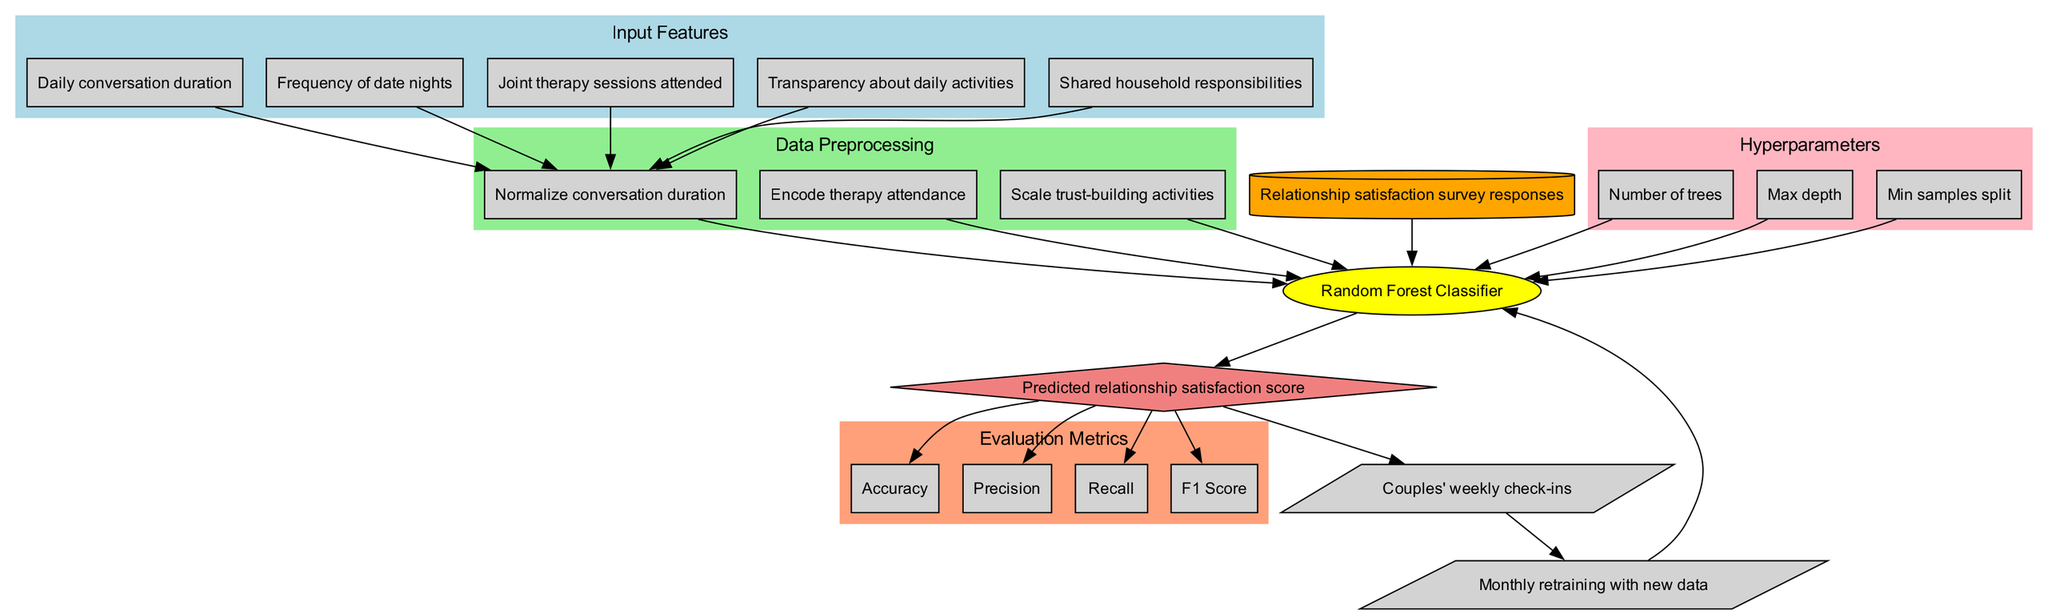What are the input features for the model? The input features are listed as separate nodes in the diagram, which include daily conversation duration, frequency of date nights, joint therapy sessions attended, transparency about daily activities, and shared household responsibilities.
Answer: Daily conversation duration, frequency of date nights, joint therapy sessions attended, transparency about daily activities, shared household responsibilities Which model is used in this diagram? The model is specified as a single node labeled “Random Forest Classifier” in the diagram, representing the type of machine learning algorithm employed.
Answer: Random Forest Classifier How many hyperparameters are considered in the model? The diagram contains a subgraph labeled “Hyperparameters” that includes three distinct nodes, each representing a hyperparameter: number of trees, max depth, and min samples split.
Answer: 3 What is the purpose of the feedback loop? The feedback loop is depicted as a parallelogram labeled “Couples' weekly check-ins,” implying it is used to gather input on the model's performance and relationship dynamics from couples periodically.
Answer: Couples' weekly check-ins What is the output of the model? The output node in the diagram is labeled as “Predicted relationship satisfaction score,” indicating this is the final result generated by the model after processing the inputs.
Answer: Predicted relationship satisfaction score Which evaluation metric is related to false positives among the predictions? Among the evaluation metrics shown, “Precision” is specifically related to false positives, as it measures the ratio of correctly predicted positive observations to the total predicted positives.
Answer: Precision What is the relationship between the training data and the model? The diagram illustrates an edge connecting the node labeled “Relationship satisfaction survey responses” (training data) directly to the “Random Forest Classifier” node (model), indicating that the model is trained on these responses.
Answer: Training data feeds into the model How often is the model updated with new data? The diagram shows a node labeled “Monthly retraining with new data,” indicating that the model is updated once a month with fresh information to improve accuracy.
Answer: Monthly What process comes after the model’s output? The diagram depicts the flow from the output node to the “Couples' weekly check-ins” feedback loop, indicating that evaluation and feedback from couples occurs after the output is generated.
Answer: Couples' weekly check-ins 